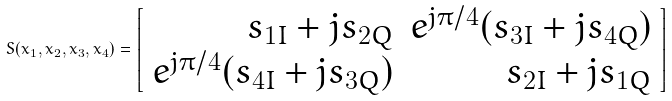<formula> <loc_0><loc_0><loc_500><loc_500>S ( x _ { 1 } , x _ { 2 } , x _ { 3 } , x _ { 4 } ) = \left [ \begin{array} { r r } s _ { 1 I } + j s _ { 2 Q } & e ^ { j \pi / 4 } ( s _ { 3 I } + j s _ { 4 Q } ) \\ e ^ { j \pi / 4 } ( s _ { 4 I } + j s _ { 3 Q } ) & s _ { 2 I } + j s _ { 1 Q } \end{array} \right ] \\</formula> 